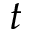Convert formula to latex. <formula><loc_0><loc_0><loc_500><loc_500>t</formula> 